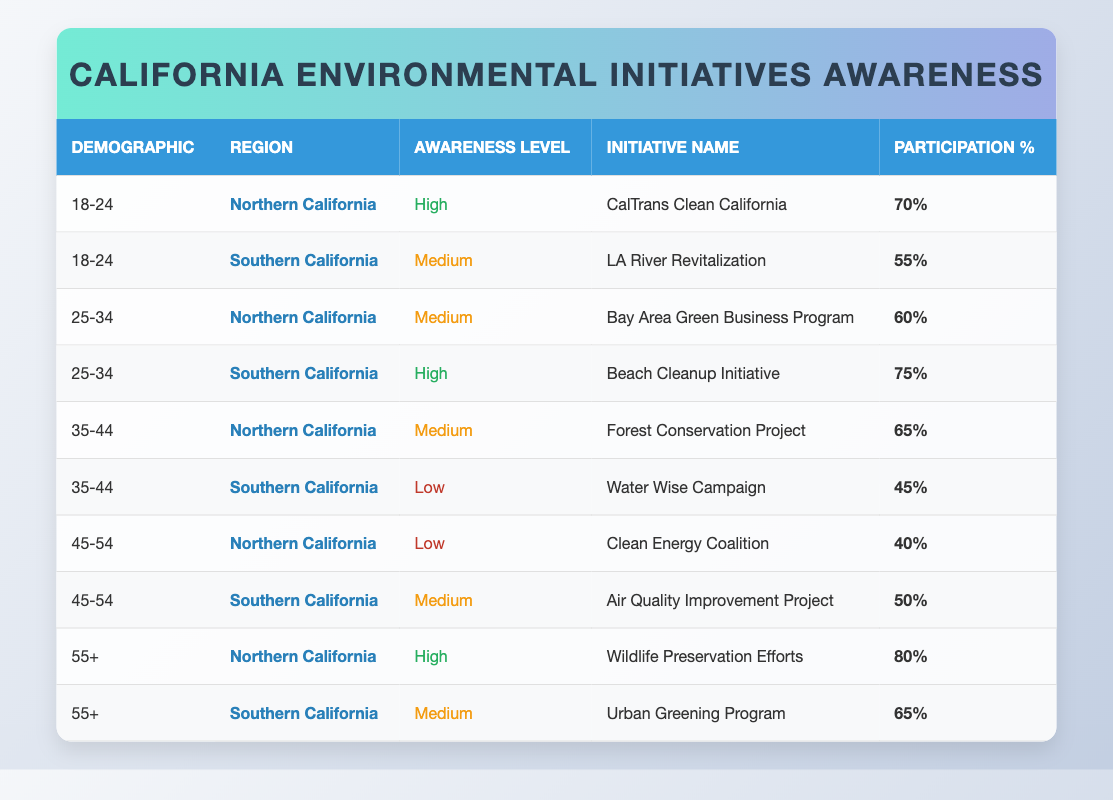What is the highest participation percentage among the initiatives listed? The highest participation percentage is listed under the initiative "Wildlife Preservation Efforts" for the 55+ demographic in Northern California, which has a participation rate of 80%.
Answer: 80% Which region shows a higher average participation rate, Northern California or Southern California? To find the average for each region, I sum the participation percentages for each region, then divide by the number of initiatives. For Northern California: (70 + 60 + 65 + 40 + 80) / 5 = 63%. For Southern California: (55 + 75 + 45 + 50 + 65) / 5 = 58%. Comparing the averages, Northern California has a higher average participation rate.
Answer: Northern California Does the demographic "45-54" in Southern California have a medium awareness level initiative? Yes, it is indicated in the table that the "Air Quality Improvement Project" for the 45-54 demographic in Southern California has a medium awareness level.
Answer: Yes Which initiative in Southern California has the lowest participation percentage? The "Water Wise Campaign" for the 35-44 demographic in Southern California has the lowest participation percentage, which is 45%.
Answer: Water Wise Campaign What is the overall average participation percentage for the demographic "25-34"? The participation percentages for the 25-34 demographic are 60% (Northern California) and 75% (Southern California). Adding these gives 135%. Dividing by 2 gives the average: 135% / 2 = 67.5%.
Answer: 67.5% For the demographic "18-24," which region has higher awareness and participation? The table shows Northern California has high awareness (CalTrans Clean California with 70% participation), while Southern California has medium awareness (LA River Revitalization with 55% participation). Thus, Northern California has both higher awareness and participation.
Answer: Northern California Do participants over the age of 55 have a high awareness level in their initiatives in both regions? Yes, the initiative "Wildlife Preservation Efforts" for Northern California has high awareness, and the "Urban Greening Program" in Southern California has medium awareness. Thus, only Northern California has high awareness.
Answer: No How many initiatives have a high awareness level in Northern California? From the table, the initiatives with high awareness in Northern California are "CalTrans Clean California" and "Wildlife Preservation Efforts." That totals two initiatives.
Answer: 2 